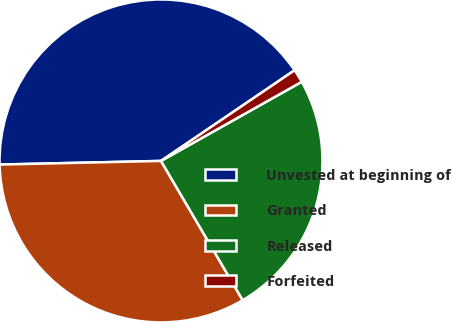Convert chart. <chart><loc_0><loc_0><loc_500><loc_500><pie_chart><fcel>Unvested at beginning of<fcel>Granted<fcel>Released<fcel>Forfeited<nl><fcel>40.87%<fcel>33.09%<fcel>24.71%<fcel>1.34%<nl></chart> 